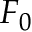<formula> <loc_0><loc_0><loc_500><loc_500>F _ { 0 }</formula> 